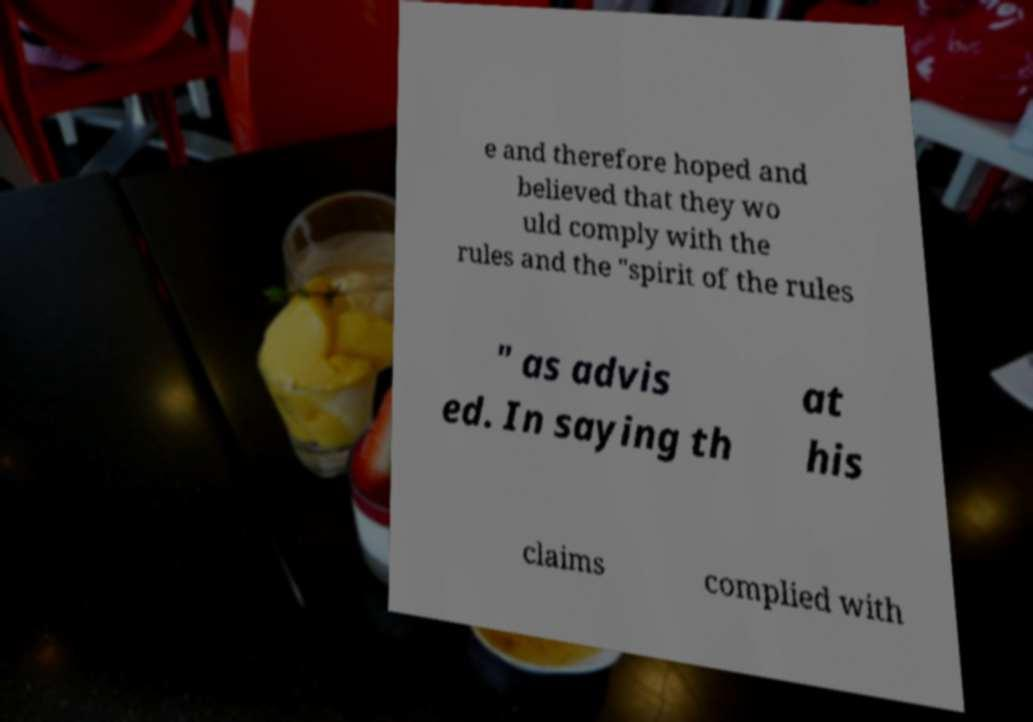Can you read and provide the text displayed in the image?This photo seems to have some interesting text. Can you extract and type it out for me? e and therefore hoped and believed that they wo uld comply with the rules and the "spirit of the rules " as advis ed. In saying th at his claims complied with 